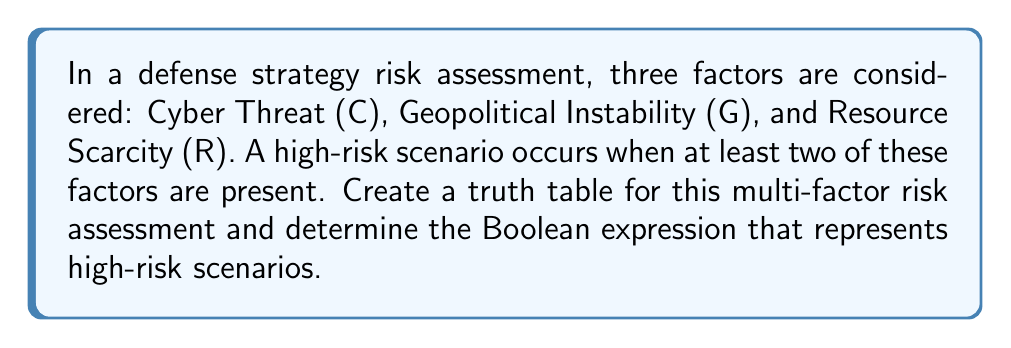Give your solution to this math problem. To solve this problem, we'll follow these steps:

1. Create a truth table with 3 input variables (C, G, R) and 1 output variable (High Risk).
2. Fill in the truth table based on the given condition.
3. Identify the high-risk scenarios (output = 1).
4. Write the Boolean expression for high-risk scenarios.

Step 1: Create the truth table

$$
\begin{array}{|c|c|c|c|}
\hline
C & G & R & \text{High Risk} \\
\hline
0 & 0 & 0 & ? \\
0 & 0 & 1 & ? \\
0 & 1 & 0 & ? \\
0 & 1 & 1 & ? \\
1 & 0 & 0 & ? \\
1 & 0 & 1 & ? \\
1 & 1 & 0 & ? \\
1 & 1 & 1 & ? \\
\hline
\end{array}
$$

Step 2: Fill in the truth table

A high-risk scenario occurs when at least two factors are present (1).

$$
\begin{array}{|c|c|c|c|}
\hline
C & G & R & \text{High Risk} \\
\hline
0 & 0 & 0 & 0 \\
0 & 0 & 1 & 0 \\
0 & 1 & 0 & 0 \\
0 & 1 & 1 & 1 \\
1 & 0 & 0 & 0 \\
1 & 0 & 1 & 1 \\
1 & 1 & 0 & 1 \\
1 & 1 & 1 & 1 \\
\hline
\end{array}
$$

Step 3: Identify high-risk scenarios

The high-risk scenarios are when the output is 1:
- C = 0, G = 1, R = 1
- C = 1, G = 0, R = 1
- C = 1, G = 1, R = 0
- C = 1, G = 1, R = 1

Step 4: Write the Boolean expression

The Boolean expression for high-risk scenarios is the sum of products (disjunctive normal form) of the high-risk rows:

$$ \text{High Risk} = \overline{C}GR + C\overline{G}R + CG\overline{R} + CGR $$

This can be simplified to:

$$ \text{High Risk} = CG + CR + GR $$

This expression represents scenarios where at least two factors are present.
Answer: $CG + CR + GR$ 